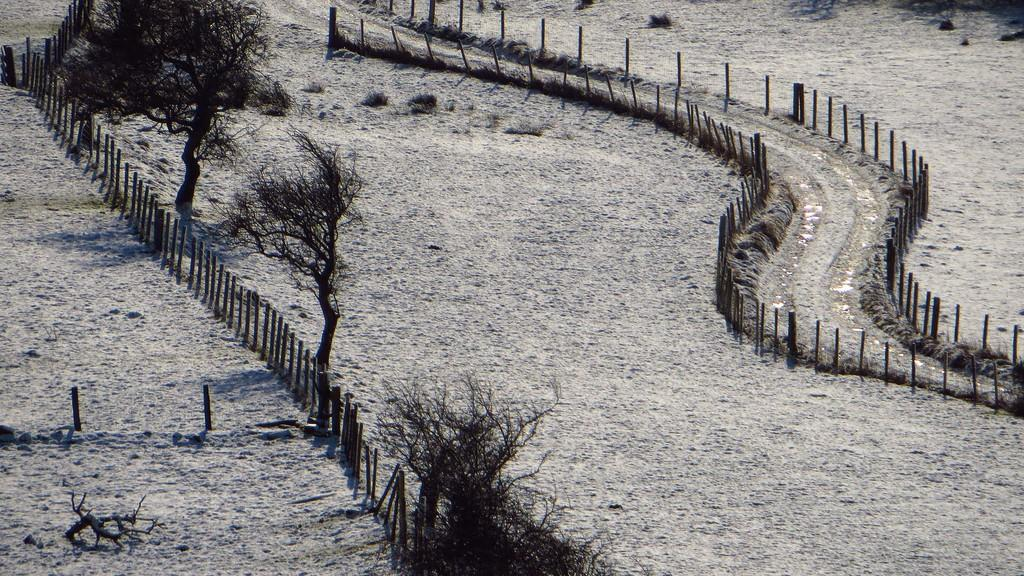What type of terrain can be seen in the image? There is land visible in the image. What type of vegetation is present in the image? There are trees in the image. What type of barrier can be seen in the image? There is fencing in the image. What type of fruit is growing on the sidewalk in the image? There is no sidewalk or fruit present in the image. How many quince trees can be seen in the image? There is no mention of quince trees in the image; only trees are mentioned. 